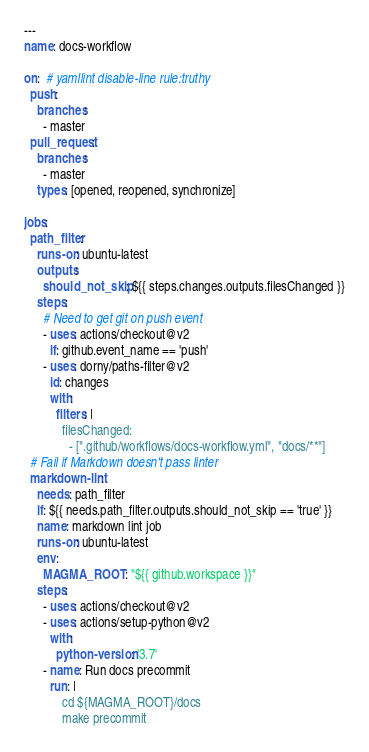Convert code to text. <code><loc_0><loc_0><loc_500><loc_500><_YAML_>---
name: docs-workflow

on:  # yamllint disable-line rule:truthy
  push:
    branches:
      - master
  pull_request:
    branches:
      - master
    types: [opened, reopened, synchronize]

jobs:
  path_filter:
    runs-on: ubuntu-latest
    outputs:
      should_not_skip: ${{ steps.changes.outputs.filesChanged }}
    steps:
      # Need to get git on push event
      - uses: actions/checkout@v2
        if: github.event_name == 'push'
      - uses: dorny/paths-filter@v2
        id: changes
        with:
          filters: |
            filesChanged:
              - [".github/workflows/docs-workflow.yml", "docs/**"]
  # Fail if Markdown doesn't pass linter
  markdown-lint:
    needs: path_filter
    if: ${{ needs.path_filter.outputs.should_not_skip == 'true' }}
    name: markdown lint job
    runs-on: ubuntu-latest
    env:
      MAGMA_ROOT: "${{ github.workspace }}"
    steps:
      - uses: actions/checkout@v2
      - uses: actions/setup-python@v2
        with:
          python-version: '3.7'
      - name: Run docs precommit
        run: |
            cd ${MAGMA_ROOT}/docs
            make precommit
</code> 